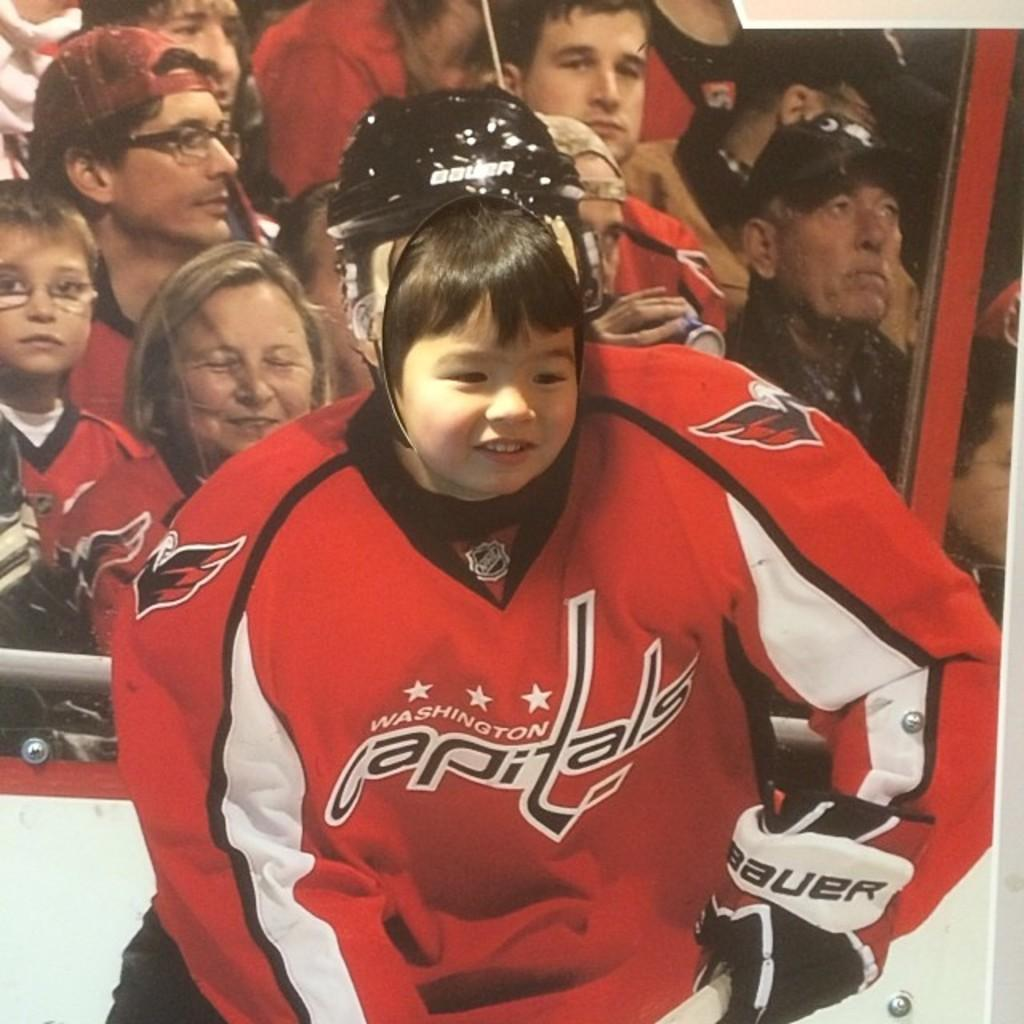Provide a one-sentence caption for the provided image. A little girl putting her face through a cutout of a capitals hockey player. 